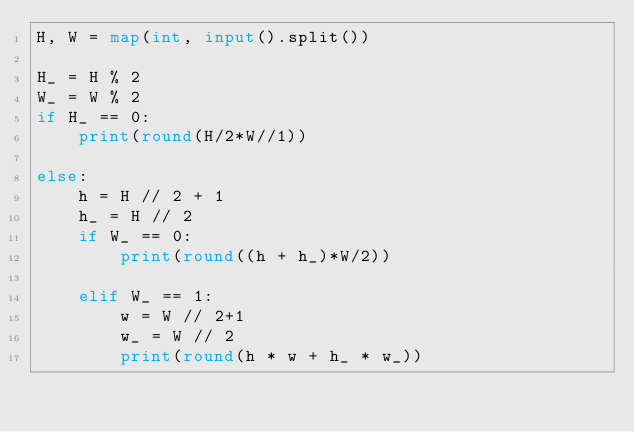<code> <loc_0><loc_0><loc_500><loc_500><_Python_>H, W = map(int, input().split())

H_ = H % 2
W_ = W % 2
if H_ == 0:
    print(round(H/2*W//1))

else:
    h = H // 2 + 1
    h_ = H // 2
    if W_ == 0:
        print(round((h + h_)*W/2))

    elif W_ == 1:
        w = W // 2+1
        w_ = W // 2
        print(round(h * w + h_ * w_))



</code> 